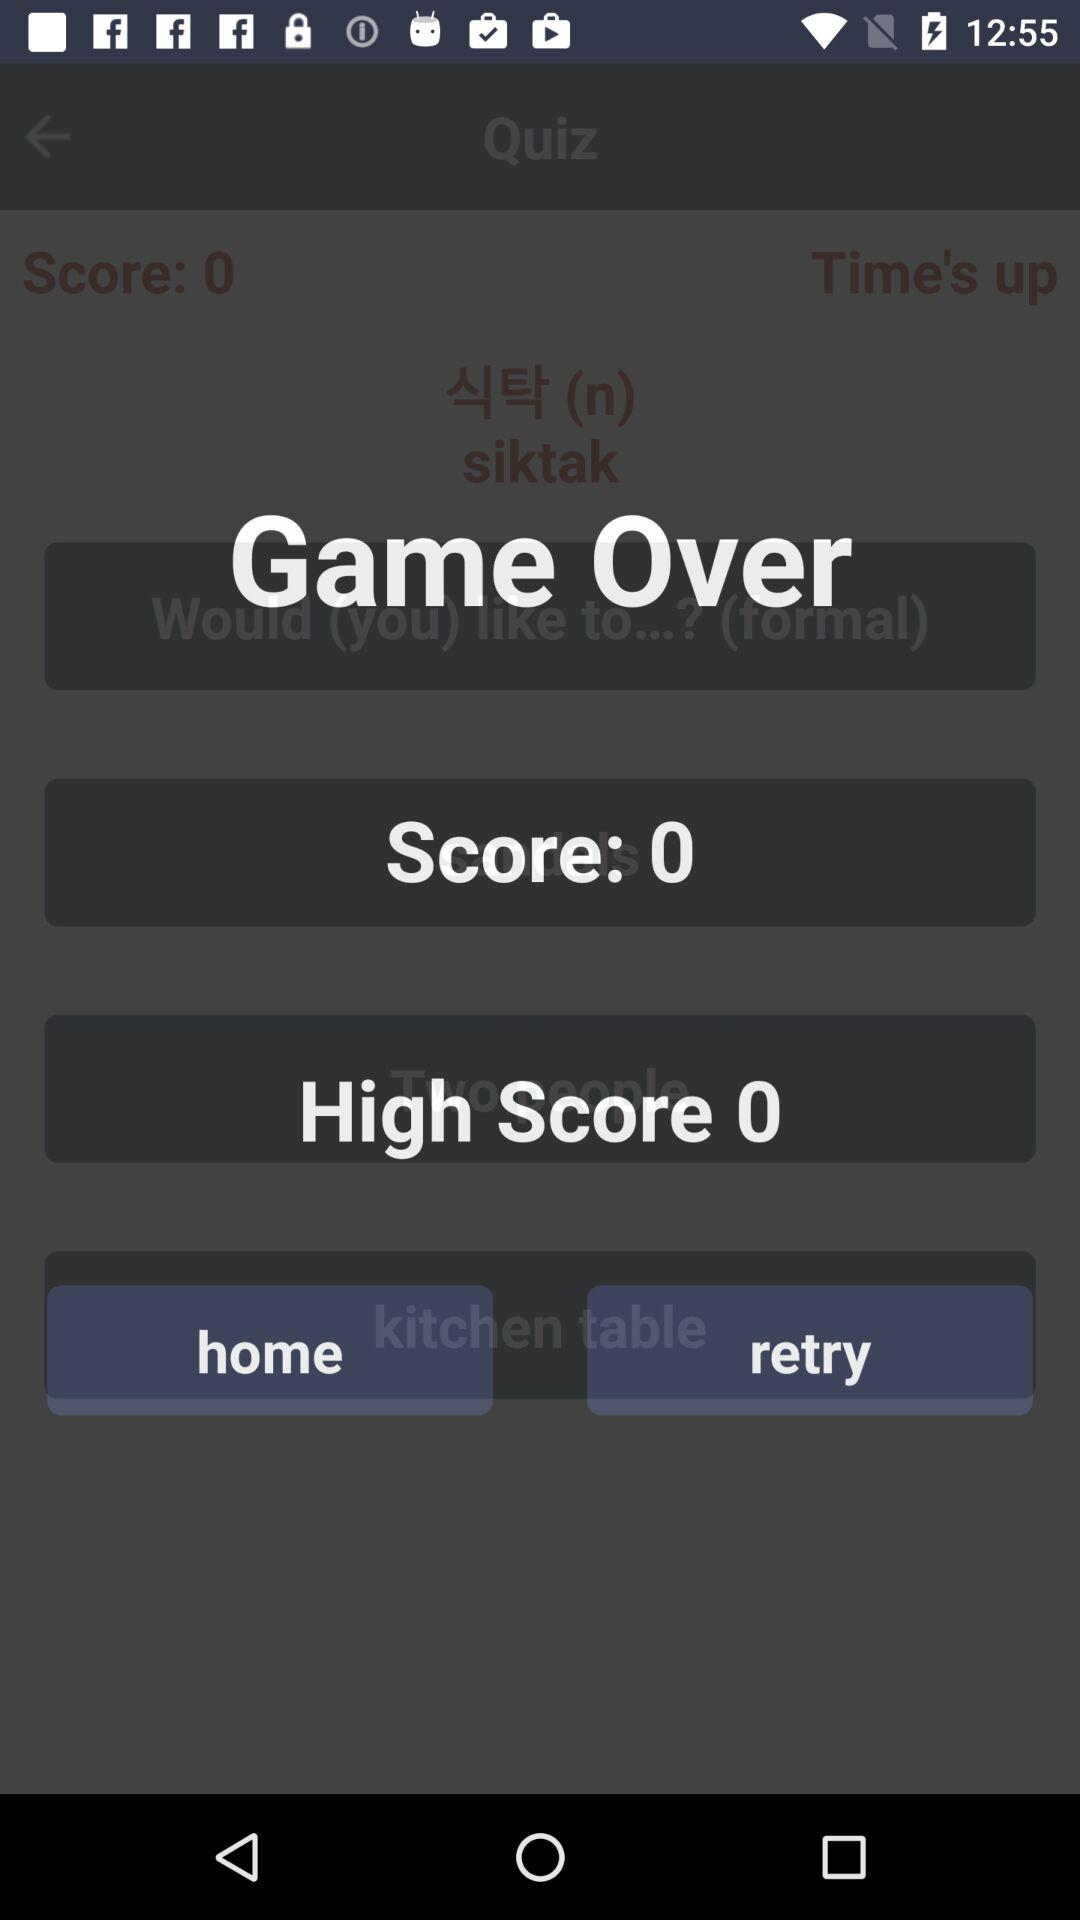What is the difference between the score and the high score?
Answer the question using a single word or phrase. 0 